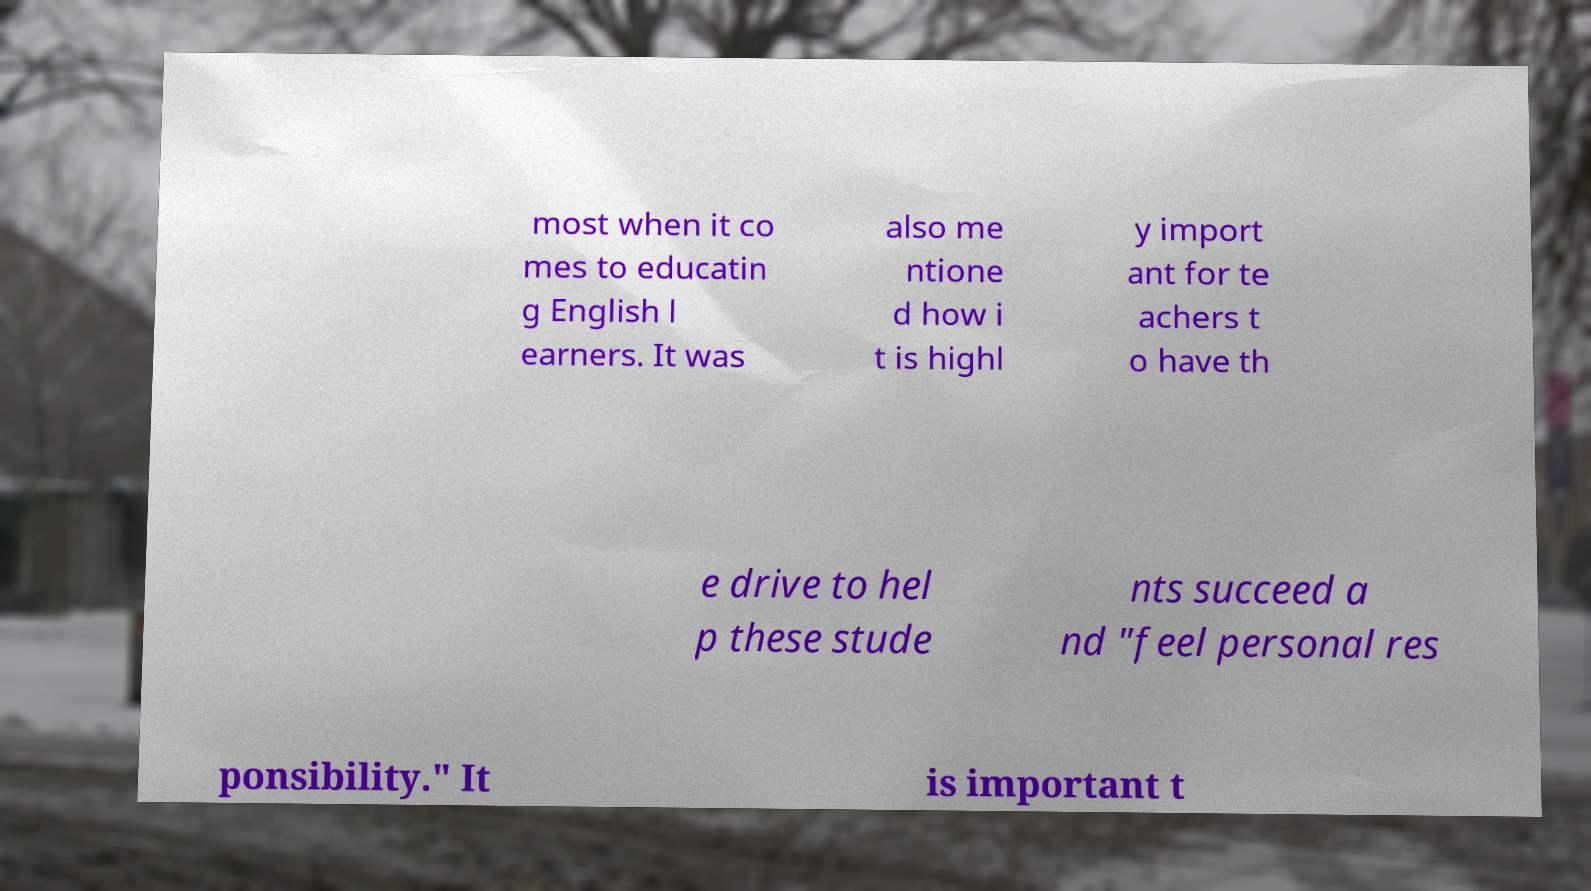I need the written content from this picture converted into text. Can you do that? most when it co mes to educatin g English l earners. It was also me ntione d how i t is highl y import ant for te achers t o have th e drive to hel p these stude nts succeed a nd "feel personal res ponsibility." It is important t 